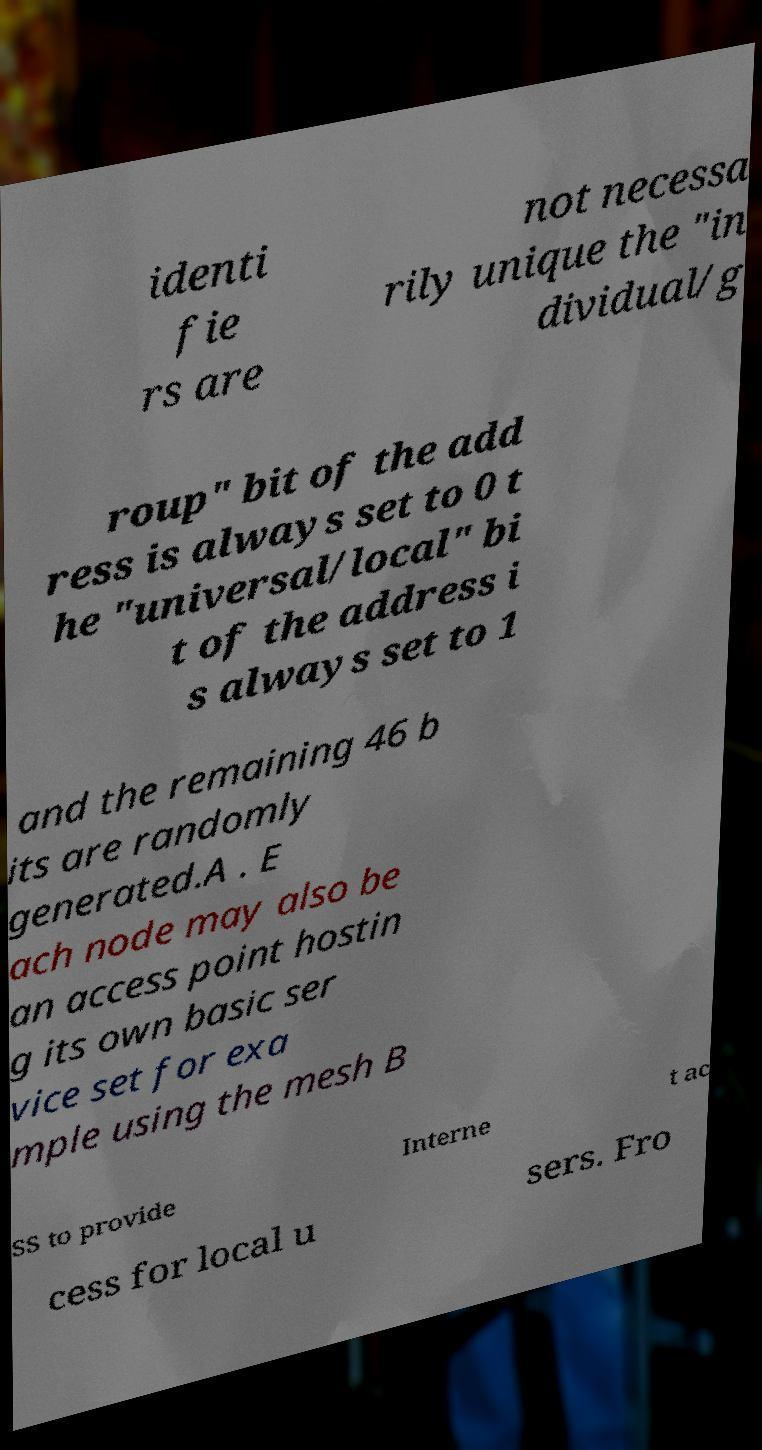Please read and relay the text visible in this image. What does it say? identi fie rs are not necessa rily unique the "in dividual/g roup" bit of the add ress is always set to 0 t he "universal/local" bi t of the address i s always set to 1 and the remaining 46 b its are randomly generated.A . E ach node may also be an access point hostin g its own basic ser vice set for exa mple using the mesh B SS to provide Interne t ac cess for local u sers. Fro 